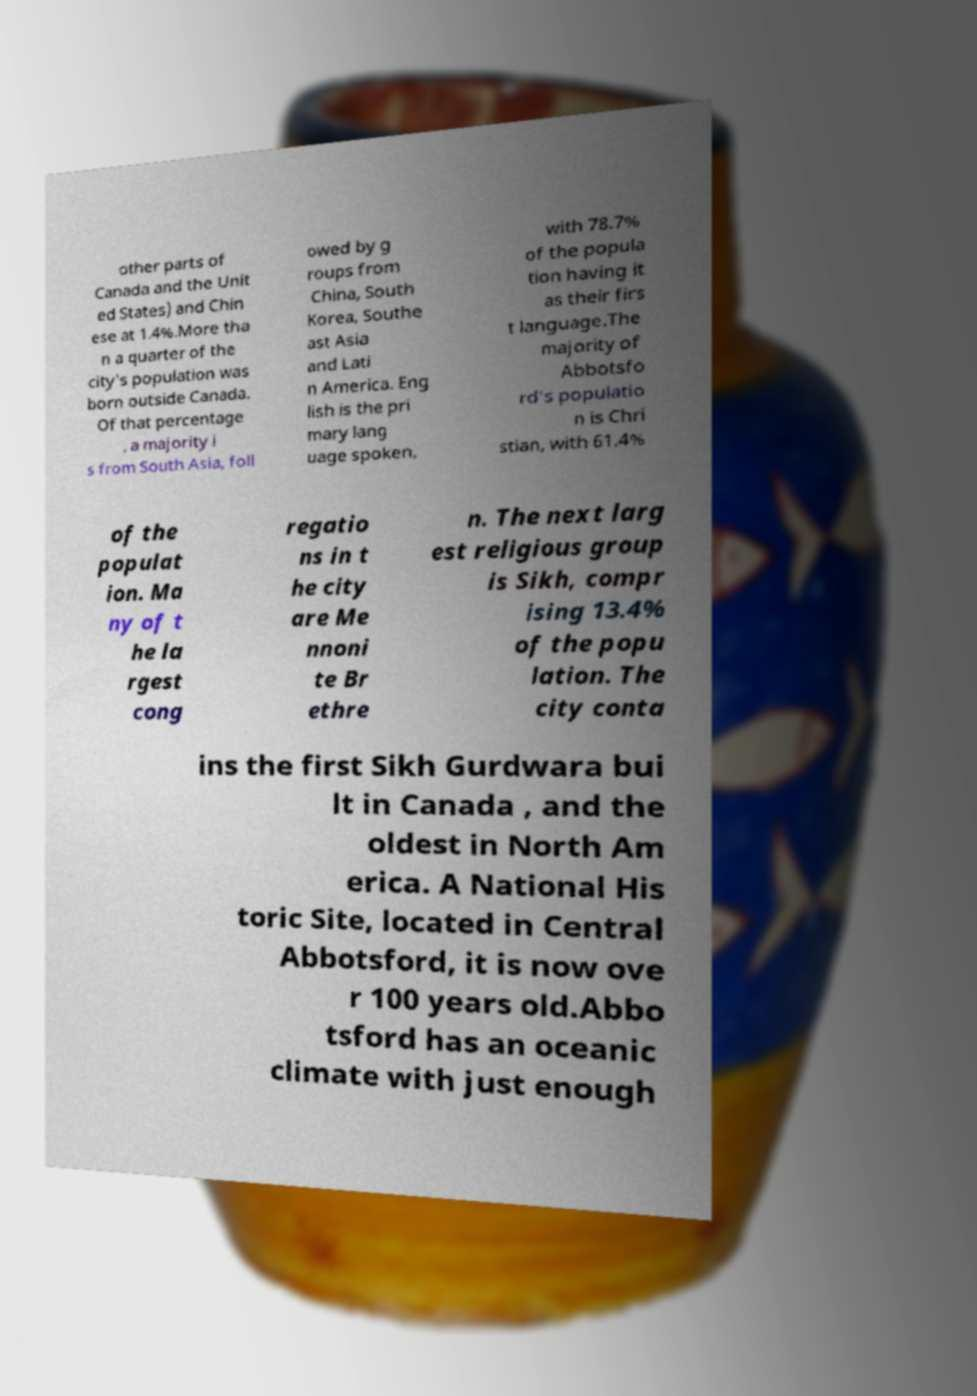Can you accurately transcribe the text from the provided image for me? other parts of Canada and the Unit ed States) and Chin ese at 1.4%.More tha n a quarter of the city's population was born outside Canada. Of that percentage , a majority i s from South Asia, foll owed by g roups from China, South Korea, Southe ast Asia and Lati n America. Eng lish is the pri mary lang uage spoken, with 78.7% of the popula tion having it as their firs t language.The majority of Abbotsfo rd's populatio n is Chri stian, with 61.4% of the populat ion. Ma ny of t he la rgest cong regatio ns in t he city are Me nnoni te Br ethre n. The next larg est religious group is Sikh, compr ising 13.4% of the popu lation. The city conta ins the first Sikh Gurdwara bui lt in Canada , and the oldest in North Am erica. A National His toric Site, located in Central Abbotsford, it is now ove r 100 years old.Abbo tsford has an oceanic climate with just enough 